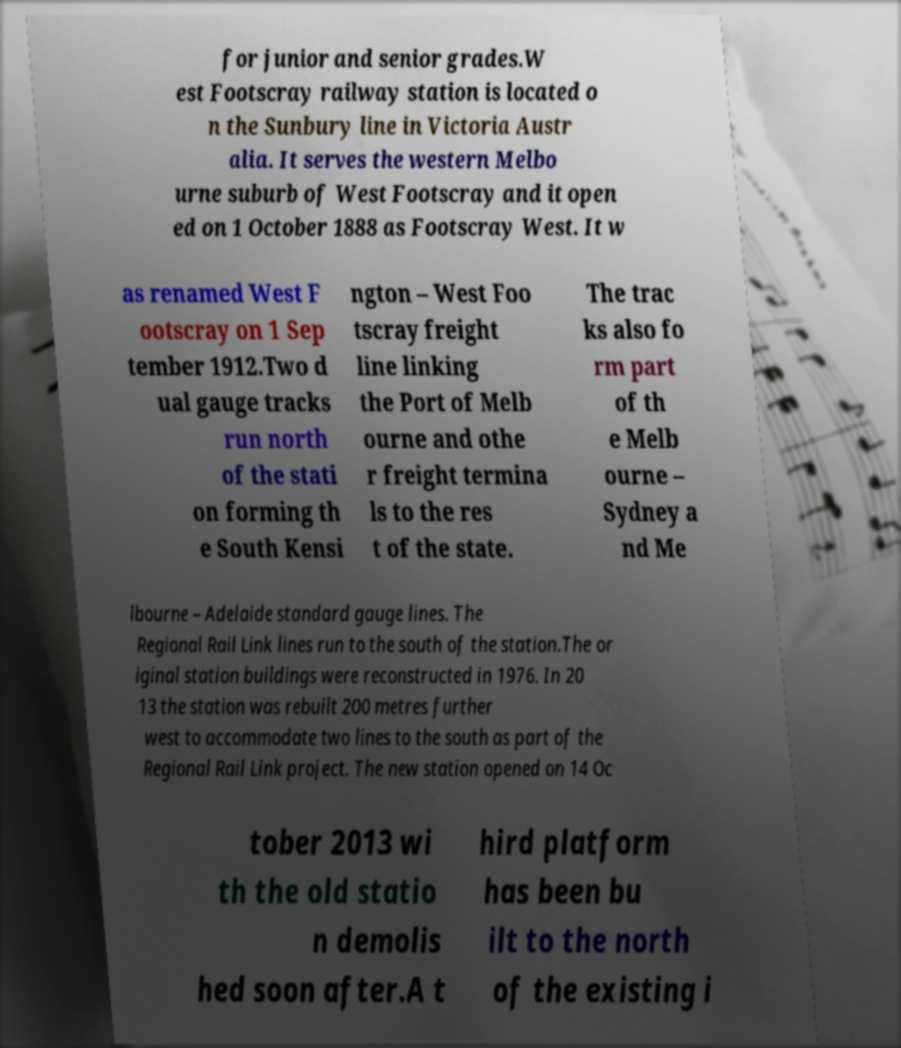Please identify and transcribe the text found in this image. for junior and senior grades.W est Footscray railway station is located o n the Sunbury line in Victoria Austr alia. It serves the western Melbo urne suburb of West Footscray and it open ed on 1 October 1888 as Footscray West. It w as renamed West F ootscray on 1 Sep tember 1912.Two d ual gauge tracks run north of the stati on forming th e South Kensi ngton – West Foo tscray freight line linking the Port of Melb ourne and othe r freight termina ls to the res t of the state. The trac ks also fo rm part of th e Melb ourne – Sydney a nd Me lbourne – Adelaide standard gauge lines. The Regional Rail Link lines run to the south of the station.The or iginal station buildings were reconstructed in 1976. In 20 13 the station was rebuilt 200 metres further west to accommodate two lines to the south as part of the Regional Rail Link project. The new station opened on 14 Oc tober 2013 wi th the old statio n demolis hed soon after.A t hird platform has been bu ilt to the north of the existing i 